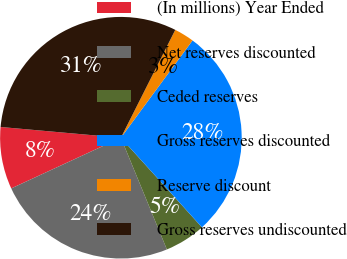<chart> <loc_0><loc_0><loc_500><loc_500><pie_chart><fcel>(In millions) Year Ended<fcel>Net reserves discounted<fcel>Ceded reserves<fcel>Gross reserves discounted<fcel>Reserve discount<fcel>Gross reserves undiscounted<nl><fcel>8.31%<fcel>24.32%<fcel>5.49%<fcel>28.19%<fcel>2.67%<fcel>31.01%<nl></chart> 